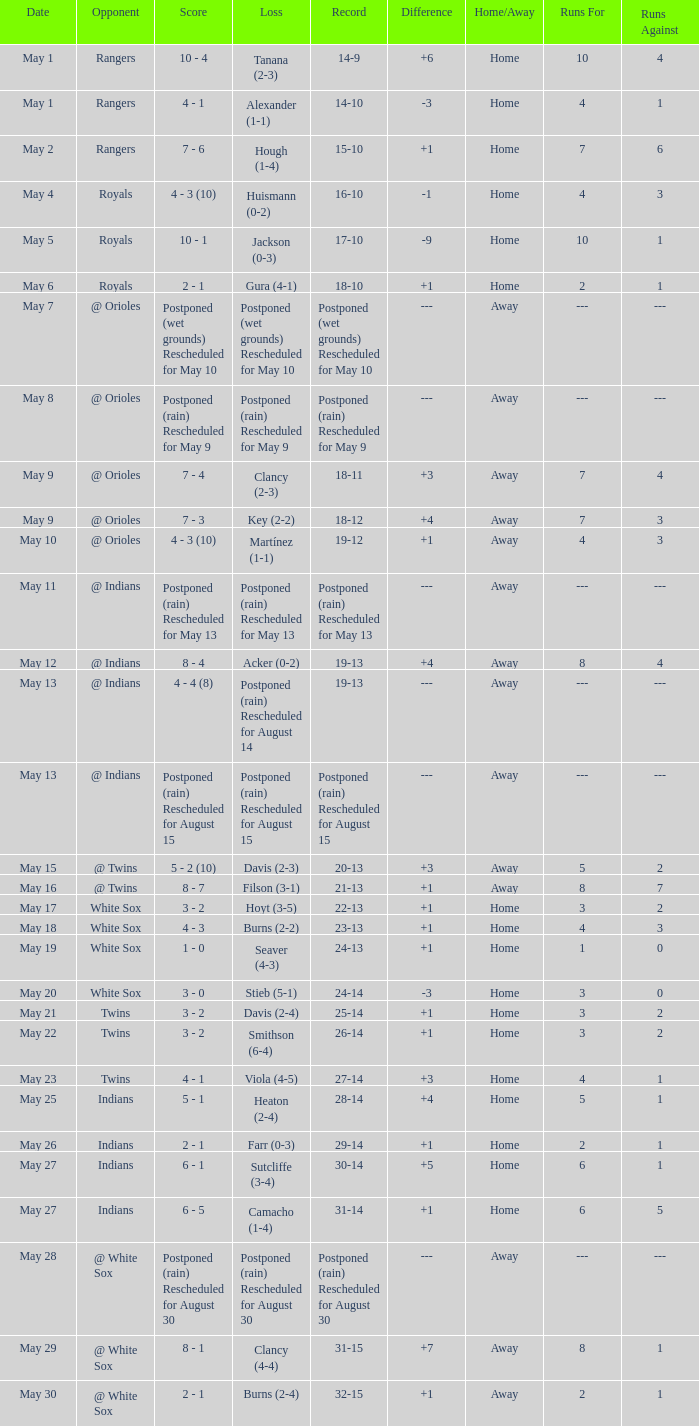Who was the opponent at the game when the record was 22-13? White Sox. 